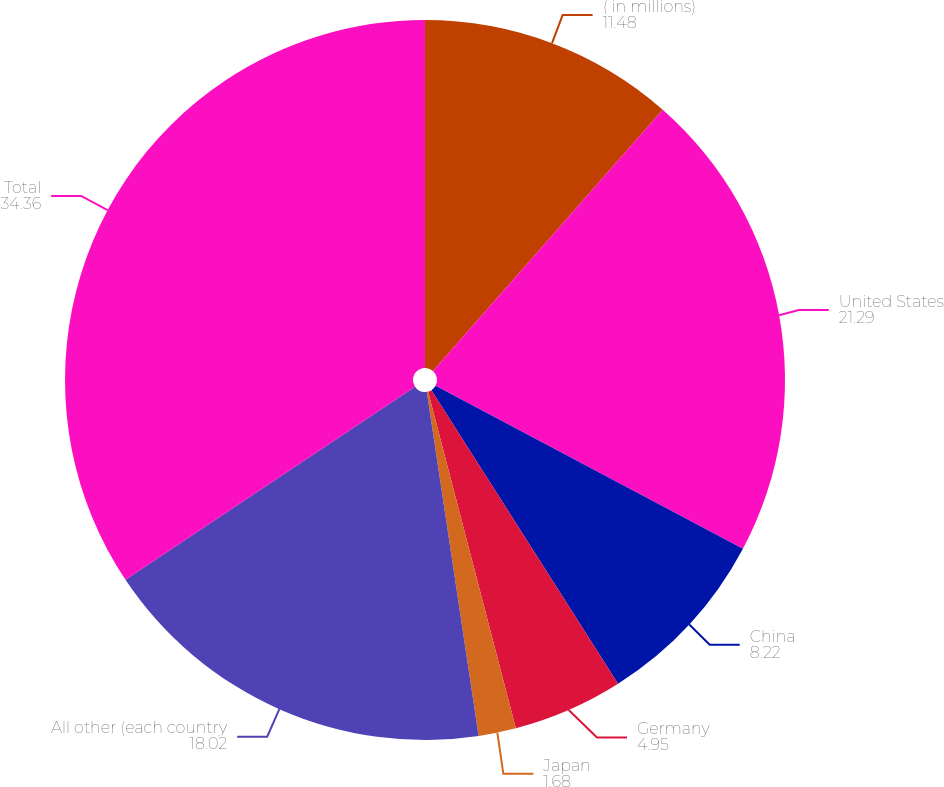<chart> <loc_0><loc_0><loc_500><loc_500><pie_chart><fcel>( in millions)<fcel>United States<fcel>China<fcel>Germany<fcel>Japan<fcel>All other (each country<fcel>Total<nl><fcel>11.48%<fcel>21.29%<fcel>8.22%<fcel>4.95%<fcel>1.68%<fcel>18.02%<fcel>34.36%<nl></chart> 